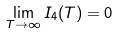<formula> <loc_0><loc_0><loc_500><loc_500>\lim _ { T \to \infty } I _ { 4 } ( T ) = 0</formula> 